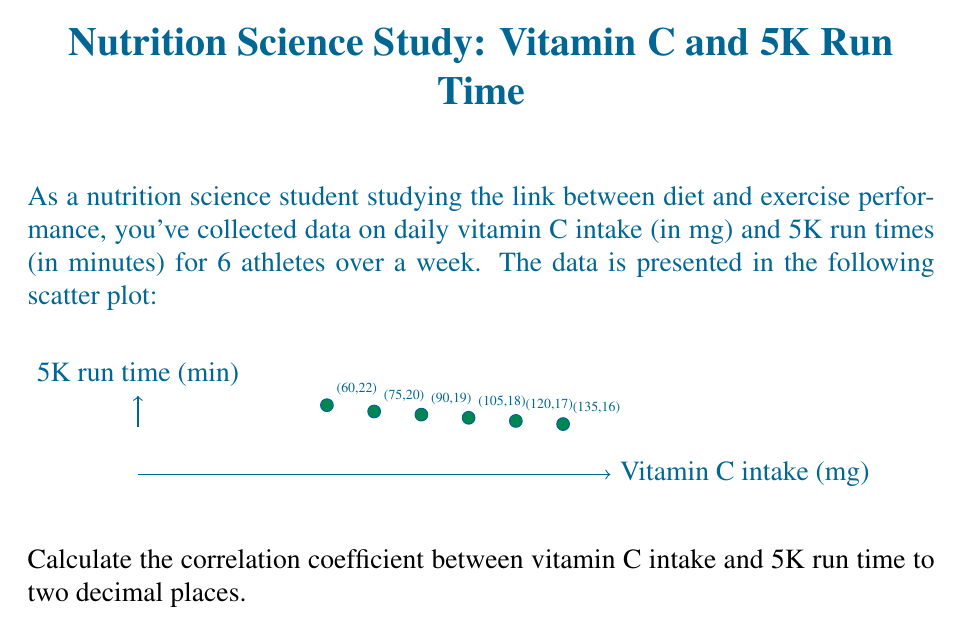Could you help me with this problem? To calculate the correlation coefficient (r), we'll use the formula:

$$r = \frac{n\sum xy - \sum x \sum y}{\sqrt{[n\sum x^2 - (\sum x)^2][n\sum y^2 - (\sum y)^2]}}$$

Where:
n = number of data points
x = vitamin C intake
y = 5K run time

Step 1: Calculate necessary sums
$\sum x = 60 + 75 + 90 + 105 + 120 + 135 = 585$
$\sum y = 22 + 20 + 19 + 18 + 17 + 16 = 112$
$\sum xy = (60)(22) + (75)(20) + (90)(19) + (105)(18) + (120)(17) + (135)(16) = 10,770$
$\sum x^2 = 60^2 + 75^2 + 90^2 + 105^2 + 120^2 + 135^2 = 61,875$
$\sum y^2 = 22^2 + 20^2 + 19^2 + 18^2 + 17^2 + 16^2 = 2,122$

Step 2: Apply the formula
$$r = \frac{6(10,770) - (585)(112)}{\sqrt{[6(61,875) - 585^2][6(2,122) - 112^2]}}$$

Step 3: Simplify
$$r = \frac{64,620 - 65,520}{\sqrt{(371,250 - 342,225)(12,732 - 12,544)}}$$
$$r = \frac{-900}{\sqrt{(29,025)(188)}}$$
$$r = \frac{-900}{\sqrt{5,456,700}}$$
$$r = \frac{-900}{2,336.00}$$
$$r = -0.3853$$

Step 4: Round to two decimal places
$r \approx -0.39$
Answer: $-0.39$ 